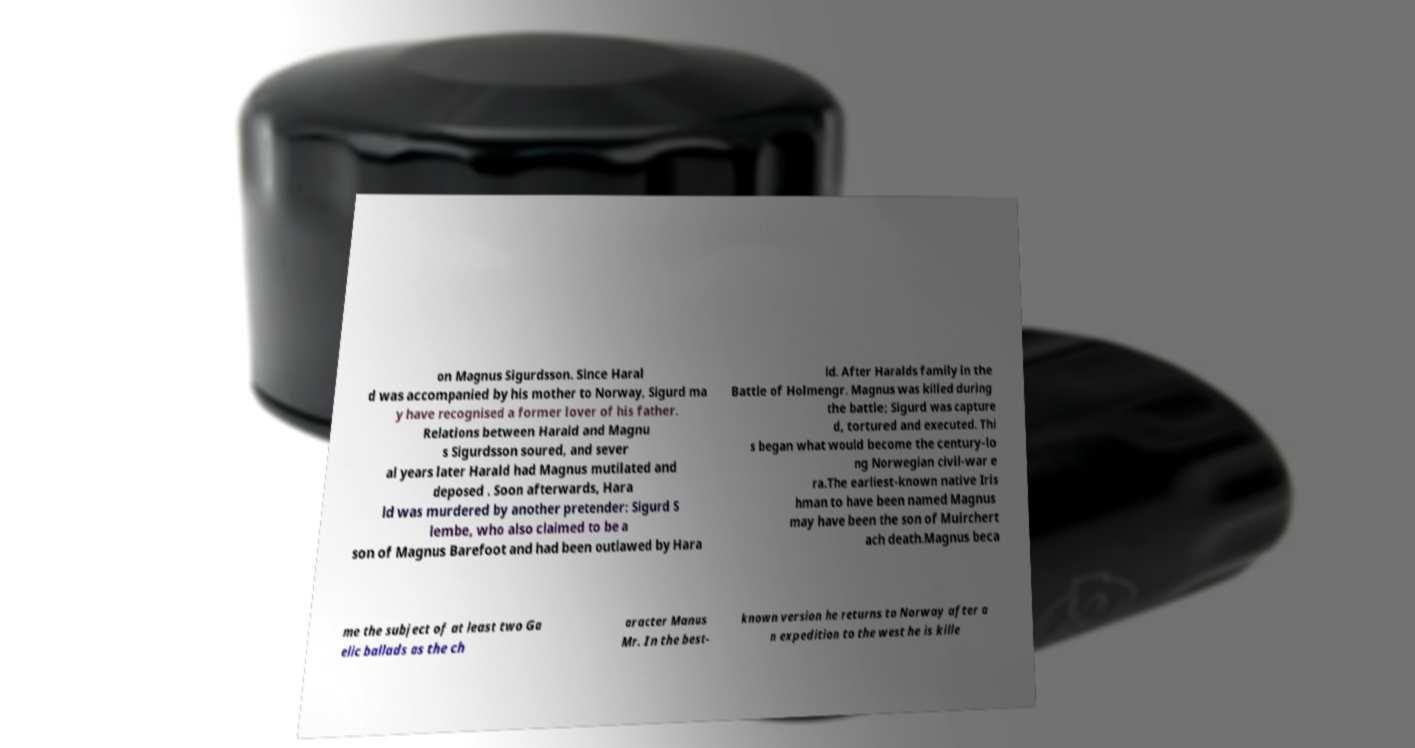Can you accurately transcribe the text from the provided image for me? on Magnus Sigurdsson. Since Haral d was accompanied by his mother to Norway, Sigurd ma y have recognised a former lover of his father. Relations between Harald and Magnu s Sigurdsson soured, and sever al years later Harald had Magnus mutilated and deposed . Soon afterwards, Hara ld was murdered by another pretender: Sigurd S lembe, who also claimed to be a son of Magnus Barefoot and had been outlawed by Hara ld. After Haralds family in the Battle of Holmengr. Magnus was killed during the battle; Sigurd was capture d, tortured and executed. Thi s began what would become the century-lo ng Norwegian civil-war e ra.The earliest-known native Iris hman to have been named Magnus may have been the son of Muirchert ach death.Magnus beca me the subject of at least two Ga elic ballads as the ch aracter Manus Mr. In the best- known version he returns to Norway after a n expedition to the west he is kille 